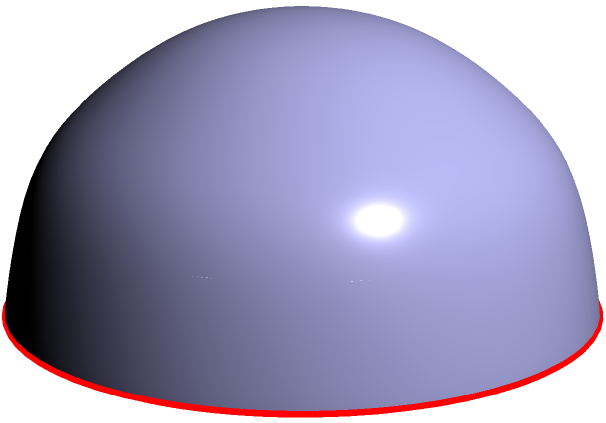In the context of social justice and policy-making, understanding non-Euclidean geometry can provide insights into global issues. Consider a great circle on a sphere, as shown in red on the diagram. How does this great circle demonstrate the principle of the shortest path between two points on a curved surface, and how might this concept relate to international policy decisions regarding global travel or resource distribution? To understand this concept and its relation to policy-making, let's break it down step-by-step:

1. Non-Euclidean Geometry: On a sphere, the rules of flat (Euclidean) geometry no longer apply. This is similar to how global issues often require thinking beyond traditional, "flat" perspectives.

2. Great Circles: The red line in the diagram represents a great circle, which is formed by the intersection of a sphere with a plane that passes through the sphere's center.

3. Shortest Path: In spherical geometry, great circles represent the shortest path between two points on the surface. This is analogous to how airplanes often fly in curved paths on flat maps to minimize travel time.

4. Curvature Visualization: The blue surface shows the sphere's curvature. This curvature affects how we must think about distances and paths on the sphere's surface.

5. Policy Implications: 
   a) Global Travel: Understanding great circles can inform policies on international flight routes, potentially reducing fuel consumption and travel times.
   b) Resource Distribution: When considering the distribution of global resources, the shortest path between two points on Earth follows a great circle, not a straight line on a flat map.

6. Social Justice Perspective: This concept highlights how geographical realities can impact access to resources and opportunities, emphasizing the need for equitable global policies that account for these non-intuitive spatial relationships.

7. Interdisciplinary Approach: By combining mathematical concepts with policy-making, we can develop more effective and just solutions to global challenges.
Answer: Great circles represent the shortest path on a sphere, illustrating how geographical realities impact global policies and resource distribution. 